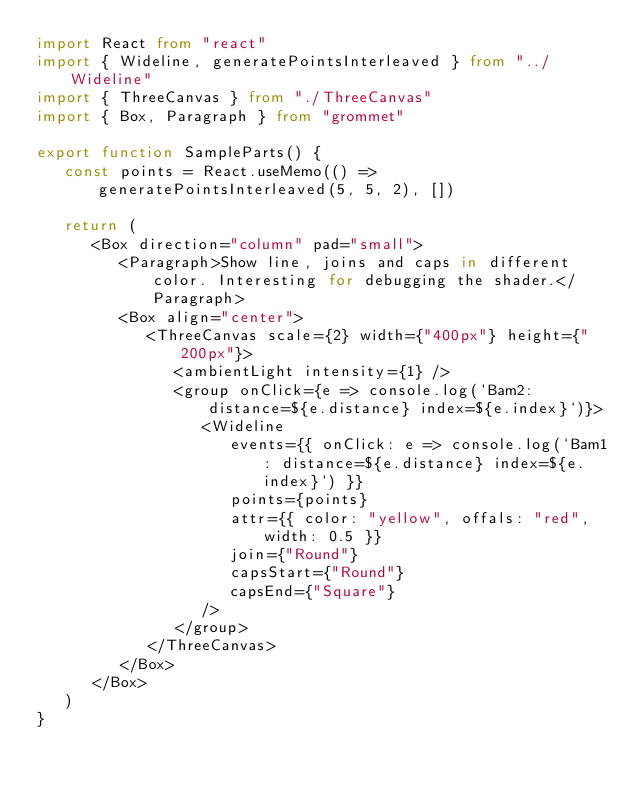<code> <loc_0><loc_0><loc_500><loc_500><_TypeScript_>import React from "react"
import { Wideline, generatePointsInterleaved } from "../Wideline"
import { ThreeCanvas } from "./ThreeCanvas"
import { Box, Paragraph } from "grommet"

export function SampleParts() {
   const points = React.useMemo(() => generatePointsInterleaved(5, 5, 2), [])

   return (
      <Box direction="column" pad="small">
         <Paragraph>Show line, joins and caps in different color. Interesting for debugging the shader.</Paragraph>
         <Box align="center">
            <ThreeCanvas scale={2} width={"400px"} height={"200px"}>
               <ambientLight intensity={1} />
               <group onClick={e => console.log(`Bam2: distance=${e.distance} index=${e.index}`)}>
                  <Wideline
                     events={{ onClick: e => console.log(`Bam1: distance=${e.distance} index=${e.index}`) }}
                     points={points}
                     attr={{ color: "yellow", offals: "red", width: 0.5 }}
                     join={"Round"}
                     capsStart={"Round"}
                     capsEnd={"Square"}
                  />
               </group>
            </ThreeCanvas>
         </Box>
      </Box>
   )
}
</code> 